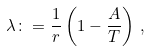Convert formula to latex. <formula><loc_0><loc_0><loc_500><loc_500>\lambda \colon = \frac { 1 } { r } \left ( 1 - \frac { A } { T } \right ) \, ,</formula> 